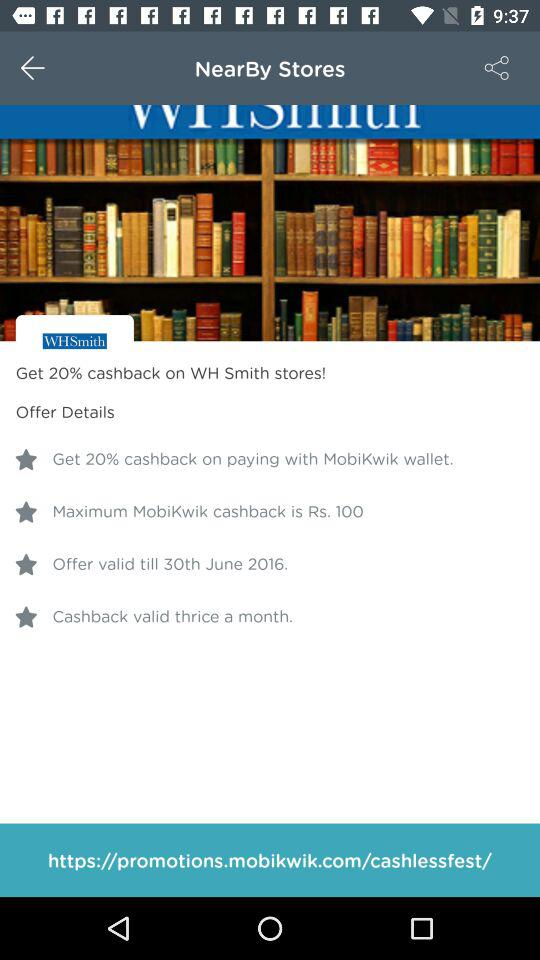How much is the maximum cashback amount?
Answer the question using a single word or phrase. Rs. 100 